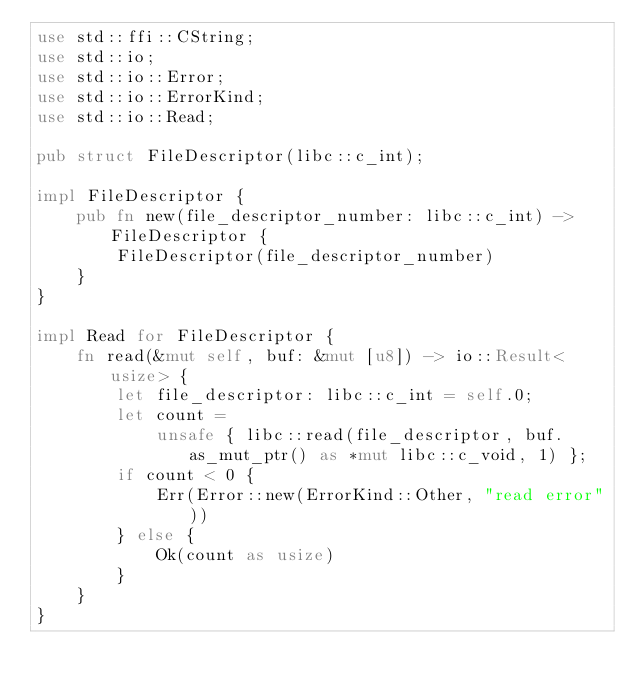<code> <loc_0><loc_0><loc_500><loc_500><_Rust_>use std::ffi::CString;
use std::io;
use std::io::Error;
use std::io::ErrorKind;
use std::io::Read;

pub struct FileDescriptor(libc::c_int);

impl FileDescriptor {
    pub fn new(file_descriptor_number: libc::c_int) -> FileDescriptor {
        FileDescriptor(file_descriptor_number)
    }
}

impl Read for FileDescriptor {
    fn read(&mut self, buf: &mut [u8]) -> io::Result<usize> {
        let file_descriptor: libc::c_int = self.0;
        let count =
            unsafe { libc::read(file_descriptor, buf.as_mut_ptr() as *mut libc::c_void, 1) };
        if count < 0 {
            Err(Error::new(ErrorKind::Other, "read error"))
        } else {
            Ok(count as usize)
        }
    }
}
</code> 